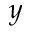Convert formula to latex. <formula><loc_0><loc_0><loc_500><loc_500>y</formula> 